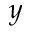Convert formula to latex. <formula><loc_0><loc_0><loc_500><loc_500>y</formula> 